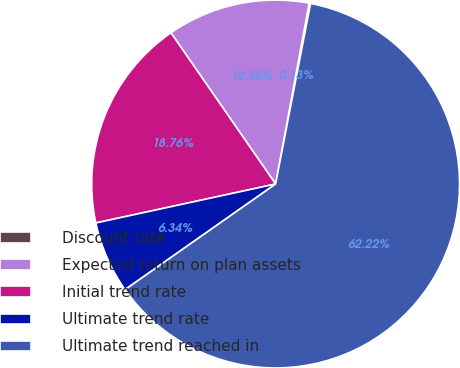<chart> <loc_0><loc_0><loc_500><loc_500><pie_chart><fcel>Discount rate<fcel>Expected return on plan assets<fcel>Initial trend rate<fcel>Ultimate trend rate<fcel>Ultimate trend reached in<nl><fcel>0.13%<fcel>12.55%<fcel>18.76%<fcel>6.34%<fcel>62.21%<nl></chart> 